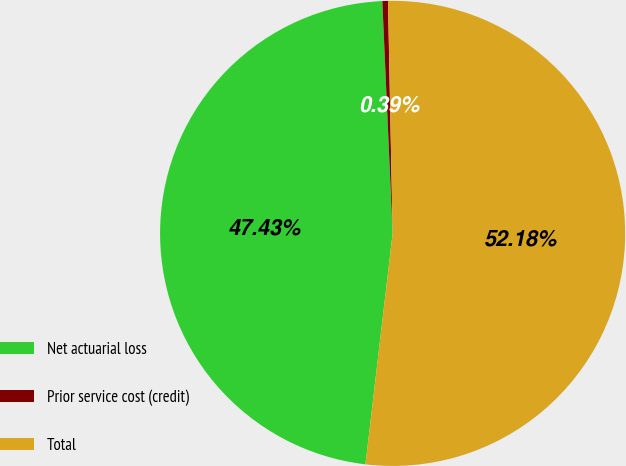Convert chart to OTSL. <chart><loc_0><loc_0><loc_500><loc_500><pie_chart><fcel>Net actuarial loss<fcel>Prior service cost (credit)<fcel>Total<nl><fcel>47.43%<fcel>0.39%<fcel>52.18%<nl></chart> 